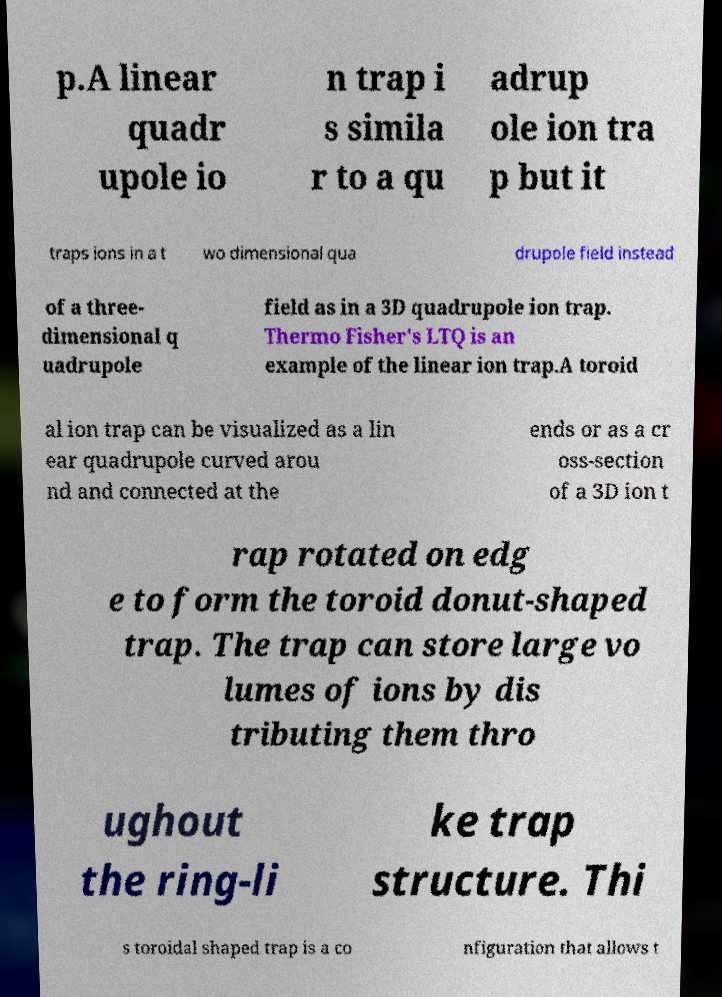Please identify and transcribe the text found in this image. p.A linear quadr upole io n trap i s simila r to a qu adrup ole ion tra p but it traps ions in a t wo dimensional qua drupole field instead of a three- dimensional q uadrupole field as in a 3D quadrupole ion trap. Thermo Fisher's LTQ is an example of the linear ion trap.A toroid al ion trap can be visualized as a lin ear quadrupole curved arou nd and connected at the ends or as a cr oss-section of a 3D ion t rap rotated on edg e to form the toroid donut-shaped trap. The trap can store large vo lumes of ions by dis tributing them thro ughout the ring-li ke trap structure. Thi s toroidal shaped trap is a co nfiguration that allows t 